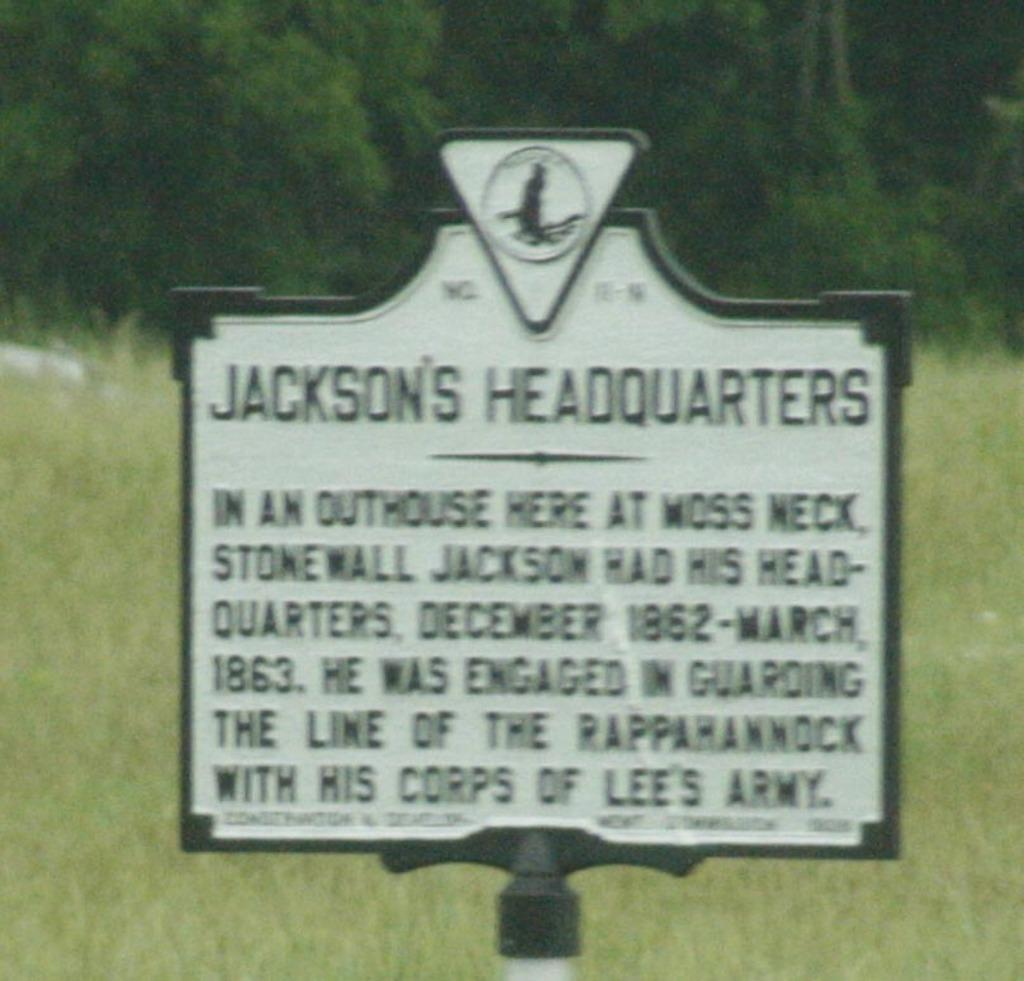What is the main object in the image? There is an address board in the image. How is the address board positioned? The address board is attached to a pole. What can be seen in the background of the image? There is grass and trees visible in the background of the image. What level of expertise does the beginner have in the image? There is no indication of any person or skill level in the image, so it is not possible to determine the expertise of a beginner. 